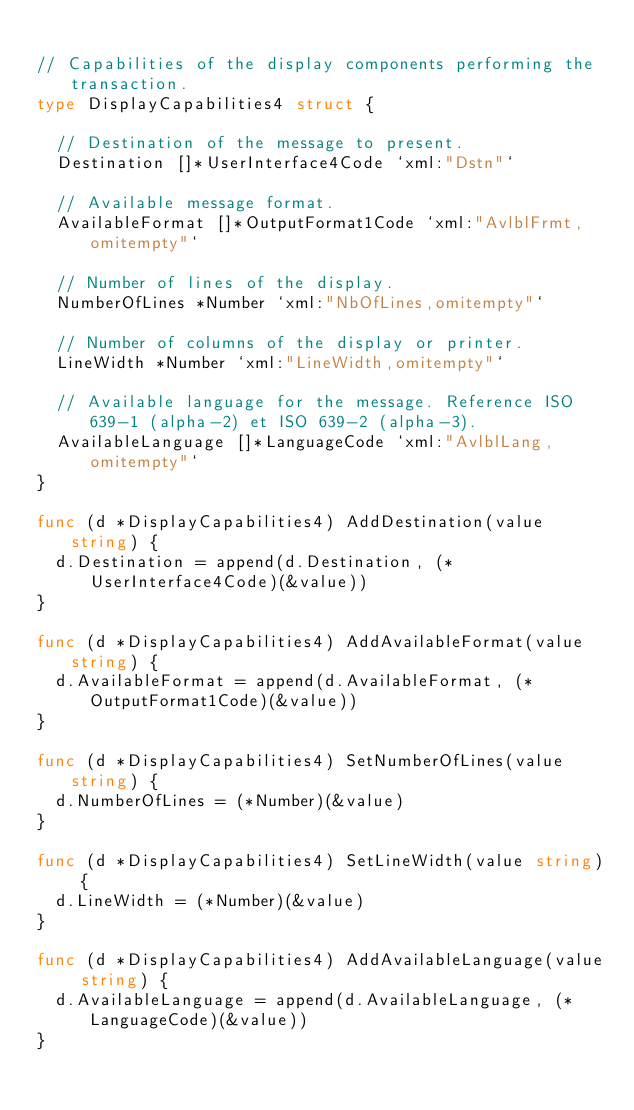<code> <loc_0><loc_0><loc_500><loc_500><_Go_>
// Capabilities of the display components performing the transaction.
type DisplayCapabilities4 struct {

	// Destination of the message to present.
	Destination []*UserInterface4Code `xml:"Dstn"`

	// Available message format.
	AvailableFormat []*OutputFormat1Code `xml:"AvlblFrmt,omitempty"`

	// Number of lines of the display.
	NumberOfLines *Number `xml:"NbOfLines,omitempty"`

	// Number of columns of the display or printer.
	LineWidth *Number `xml:"LineWidth,omitempty"`

	// Available language for the message. Reference ISO 639-1 (alpha-2) et ISO 639-2 (alpha-3).
	AvailableLanguage []*LanguageCode `xml:"AvlblLang,omitempty"`
}

func (d *DisplayCapabilities4) AddDestination(value string) {
	d.Destination = append(d.Destination, (*UserInterface4Code)(&value))
}

func (d *DisplayCapabilities4) AddAvailableFormat(value string) {
	d.AvailableFormat = append(d.AvailableFormat, (*OutputFormat1Code)(&value))
}

func (d *DisplayCapabilities4) SetNumberOfLines(value string) {
	d.NumberOfLines = (*Number)(&value)
}

func (d *DisplayCapabilities4) SetLineWidth(value string) {
	d.LineWidth = (*Number)(&value)
}

func (d *DisplayCapabilities4) AddAvailableLanguage(value string) {
	d.AvailableLanguage = append(d.AvailableLanguage, (*LanguageCode)(&value))
}
</code> 